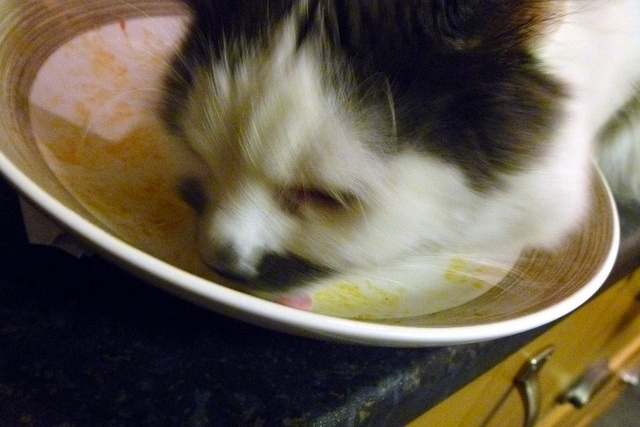Describe the objects in this image and their specific colors. I can see cat in tan, black, darkgray, lightgray, and olive tones and bowl in black, olive, gray, white, and darkgray tones in this image. 